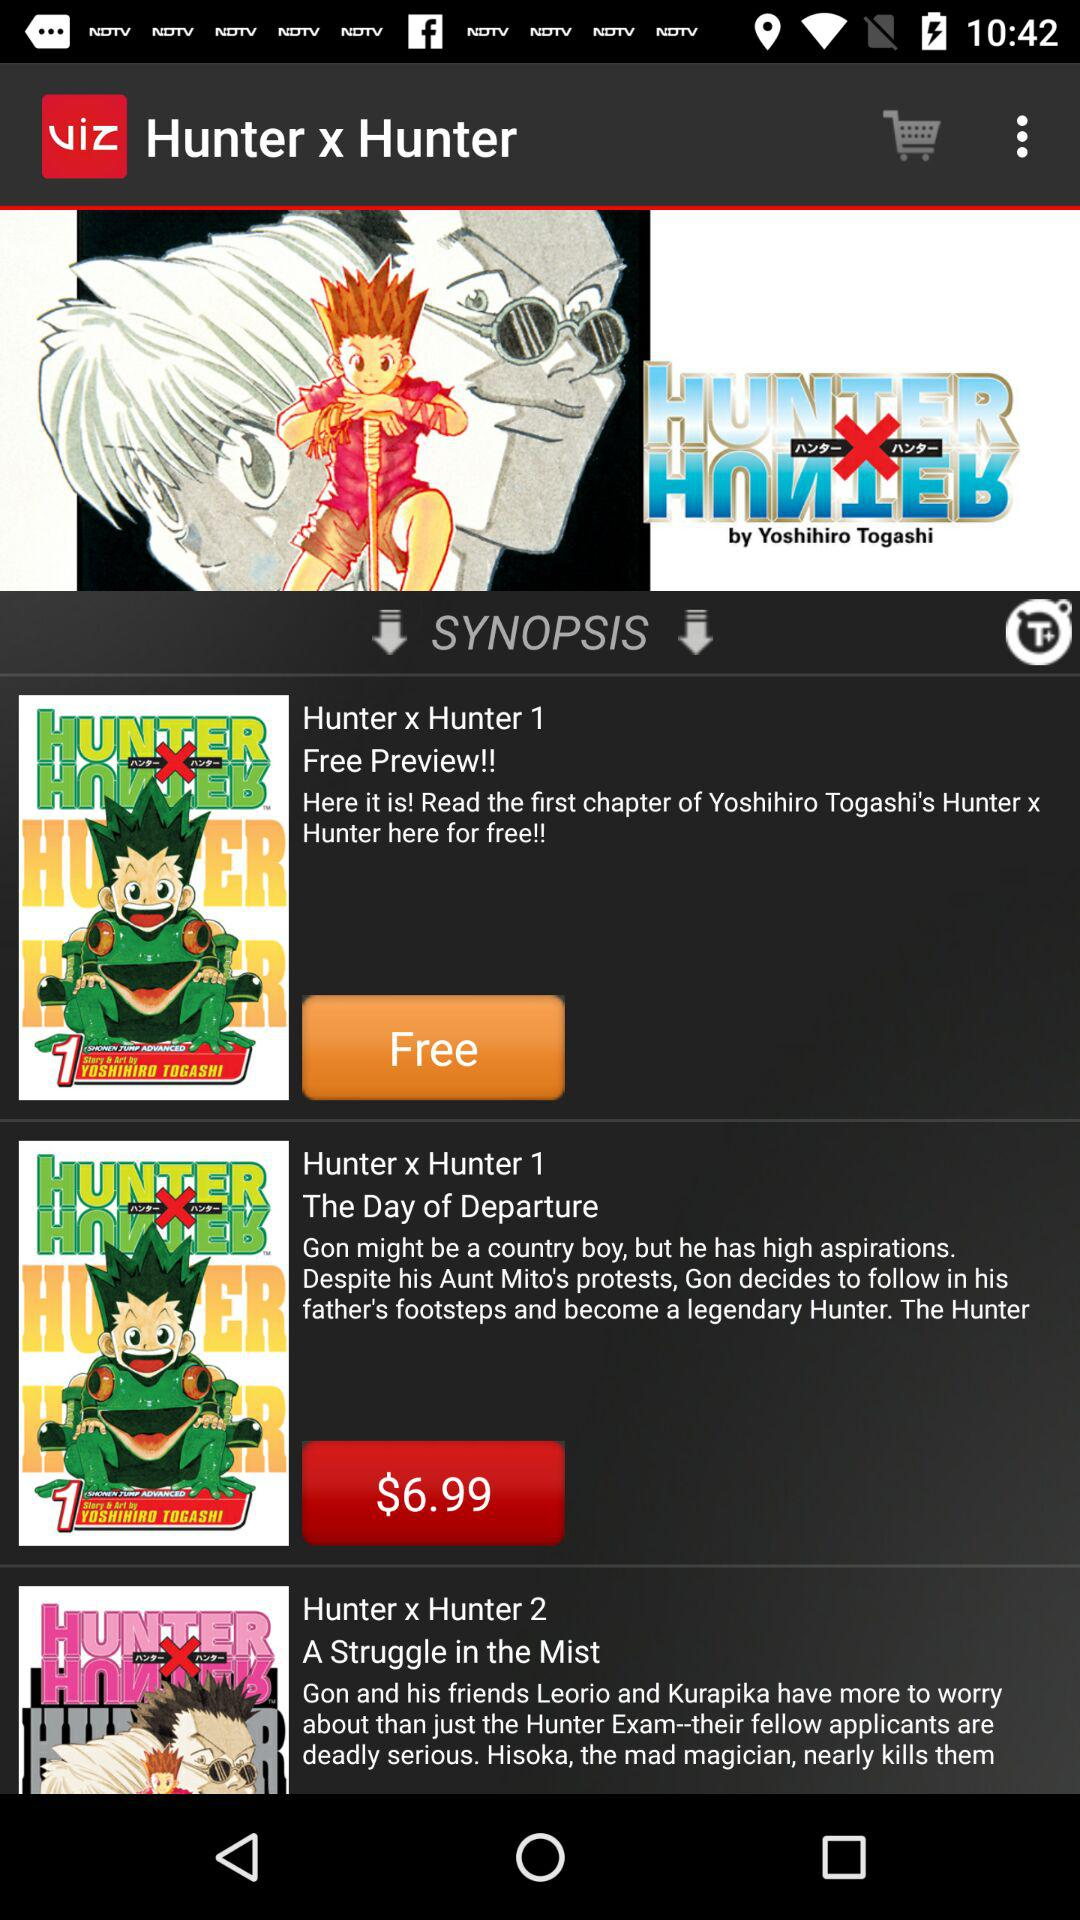How many chapters are available to read for free?
Answer the question using a single word or phrase. 1 